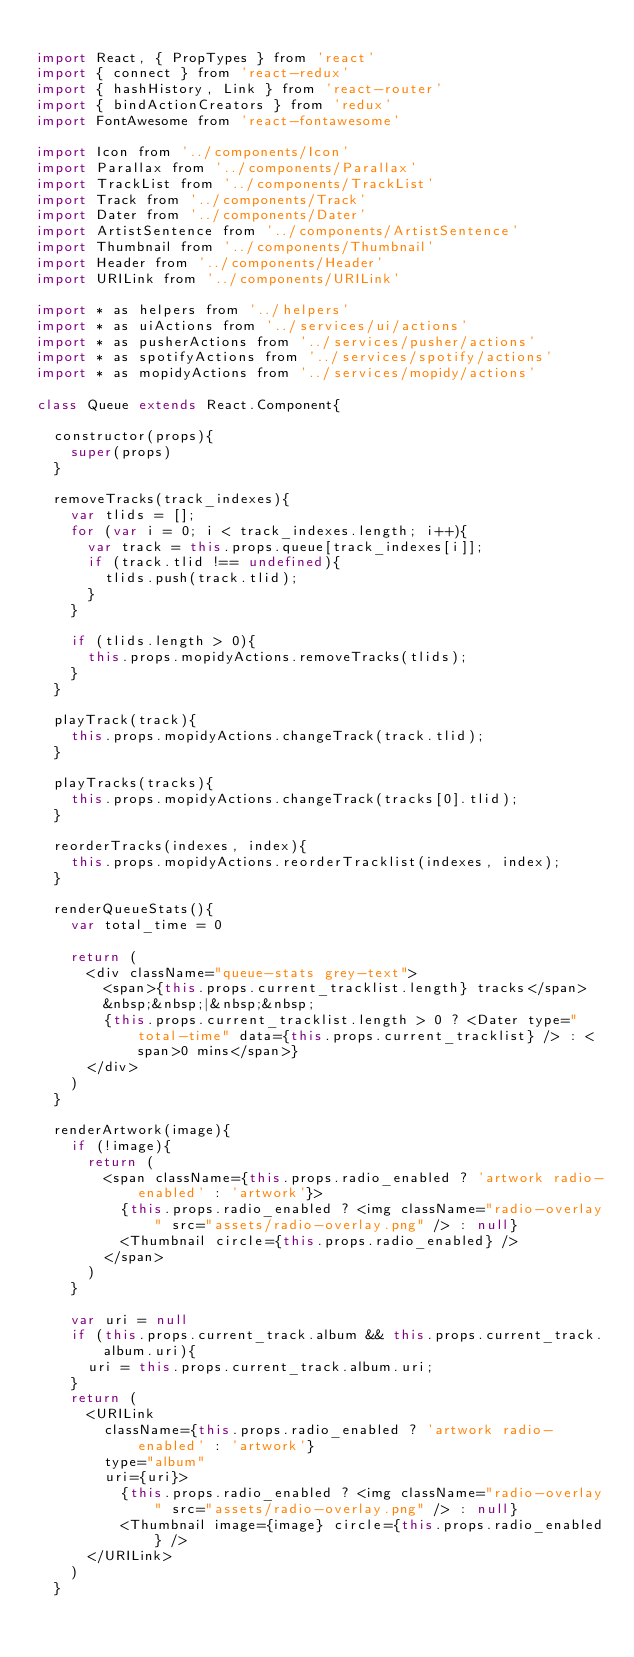<code> <loc_0><loc_0><loc_500><loc_500><_JavaScript_>
import React, { PropTypes } from 'react'
import { connect } from 'react-redux'
import { hashHistory, Link } from 'react-router'
import { bindActionCreators } from 'redux'
import FontAwesome from 'react-fontawesome'

import Icon from '../components/Icon'
import Parallax from '../components/Parallax'
import TrackList from '../components/TrackList'
import Track from '../components/Track'
import Dater from '../components/Dater'
import ArtistSentence from '../components/ArtistSentence'
import Thumbnail from '../components/Thumbnail'
import Header from '../components/Header'
import URILink from '../components/URILink'

import * as helpers from '../helpers'
import * as uiActions from '../services/ui/actions'
import * as pusherActions from '../services/pusher/actions'
import * as spotifyActions from '../services/spotify/actions'
import * as mopidyActions from '../services/mopidy/actions'

class Queue extends React.Component{

	constructor(props){
		super(props)
	}

	removeTracks(track_indexes){
		var tlids = [];
		for (var i = 0; i < track_indexes.length; i++){
			var track = this.props.queue[track_indexes[i]];
			if (track.tlid !== undefined){
				tlids.push(track.tlid);
			}
		}

		if (tlids.length > 0){
			this.props.mopidyActions.removeTracks(tlids);
		}
	}

	playTrack(track){
		this.props.mopidyActions.changeTrack(track.tlid);
	}

	playTracks(tracks){
		this.props.mopidyActions.changeTrack(tracks[0].tlid);
	}

	reorderTracks(indexes, index){
		this.props.mopidyActions.reorderTracklist(indexes, index);
	}

	renderQueueStats(){
		var total_time = 0

		return (
			<div className="queue-stats grey-text">
				<span>{this.props.current_tracklist.length} tracks</span>
				&nbsp;&nbsp;|&nbsp;&nbsp;
				{this.props.current_tracklist.length > 0 ? <Dater type="total-time" data={this.props.current_tracklist} /> : <span>0 mins</span>}
			</div>
		)
	}

	renderArtwork(image){
		if (!image){
			return (
				<span className={this.props.radio_enabled ? 'artwork radio-enabled' : 'artwork'}>
					{this.props.radio_enabled ? <img className="radio-overlay" src="assets/radio-overlay.png" /> : null}
					<Thumbnail circle={this.props.radio_enabled} />
				</span>
			)
		}

		var uri = null
		if (this.props.current_track.album && this.props.current_track.album.uri){
			uri = this.props.current_track.album.uri;
		}
		return (
			<URILink
				className={this.props.radio_enabled ? 'artwork radio-enabled' : 'artwork'}
				type="album" 
				uri={uri}>
					{this.props.radio_enabled ? <img className="radio-overlay" src="assets/radio-overlay.png" /> : null}
					<Thumbnail image={image} circle={this.props.radio_enabled} />
			</URILink>
		)
	}</code> 